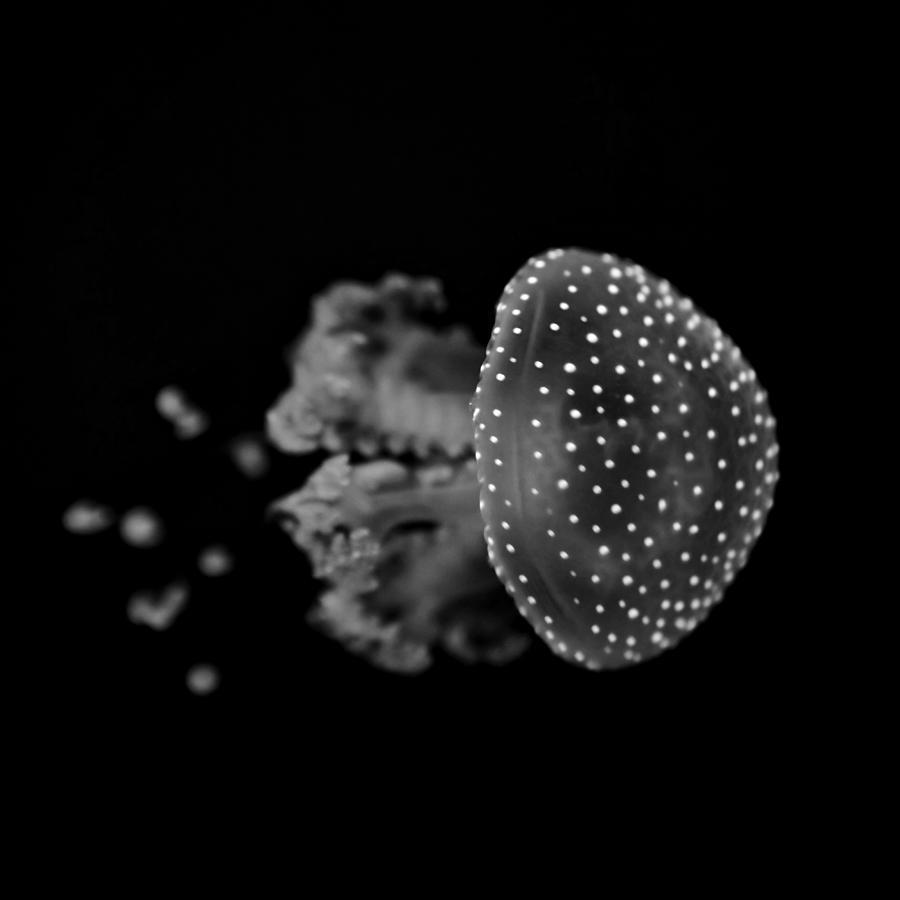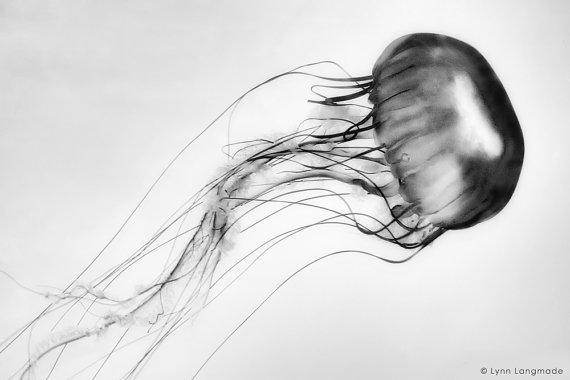The first image is the image on the left, the second image is the image on the right. For the images shown, is this caption "The image on the right shows only a single jellyfish swimming to the right." true? Answer yes or no. Yes. 